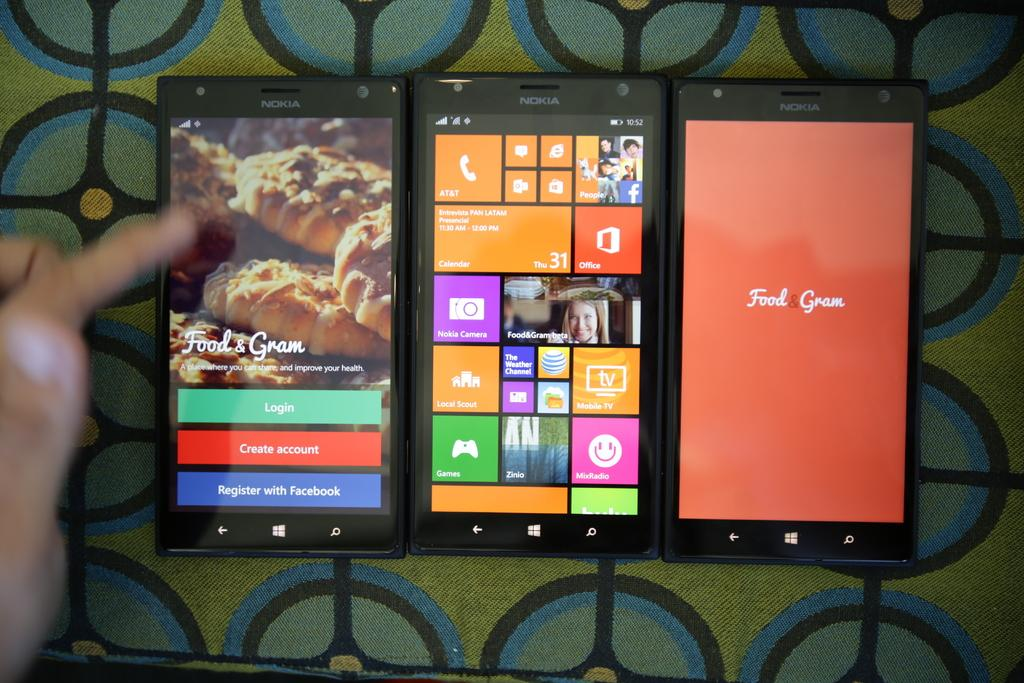Provide a one-sentence caption for the provided image. An app called Food & Gram is displayed on three cell phones. 